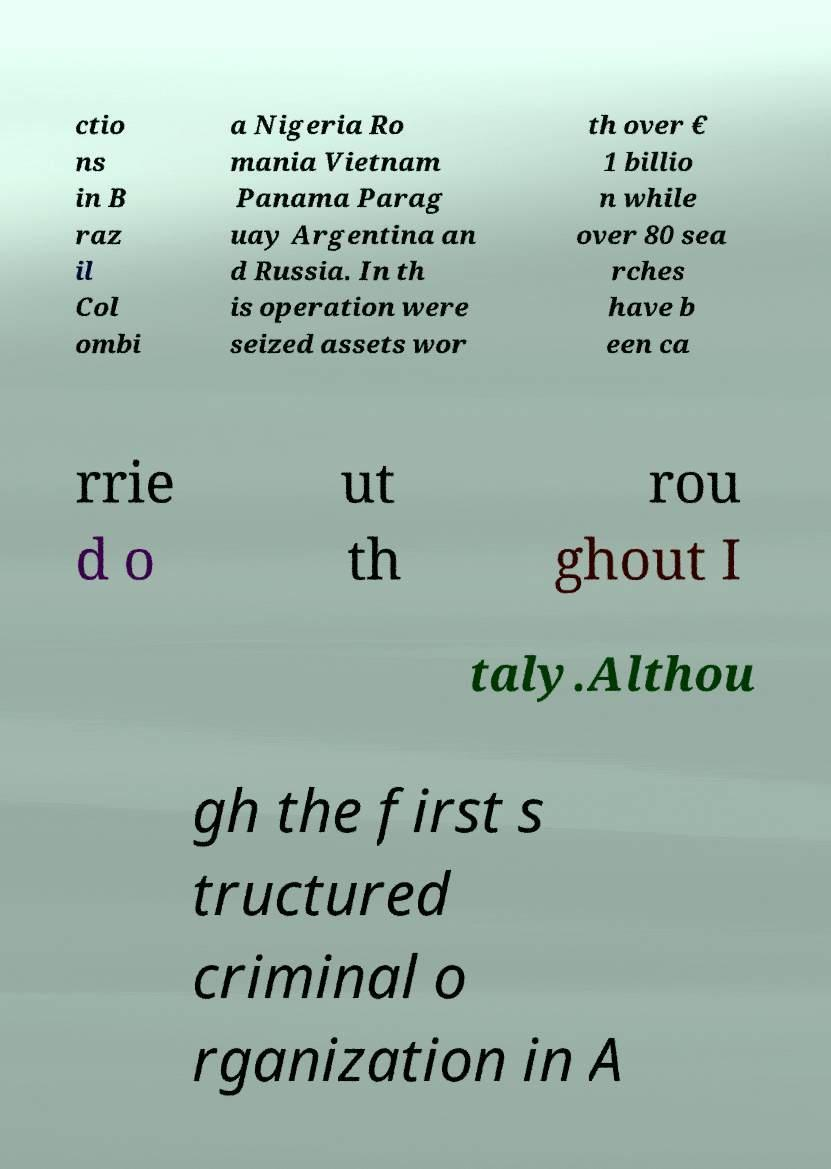Could you assist in decoding the text presented in this image and type it out clearly? ctio ns in B raz il Col ombi a Nigeria Ro mania Vietnam Panama Parag uay Argentina an d Russia. In th is operation were seized assets wor th over € 1 billio n while over 80 sea rches have b een ca rrie d o ut th rou ghout I taly.Althou gh the first s tructured criminal o rganization in A 